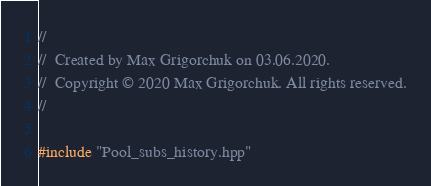Convert code to text. <code><loc_0><loc_0><loc_500><loc_500><_C++_>//
//  Created by Max Grigorchuk on 03.06.2020.
//  Copyright © 2020 Max Grigorchuk. All rights reserved.
//

#include "Pool_subs_history.hpp"
</code> 